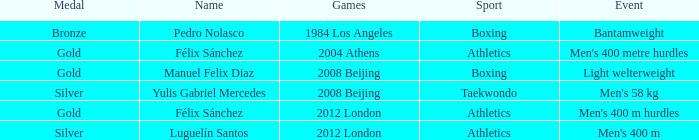Which Games had a Name of manuel felix diaz? 2008 Beijing. 